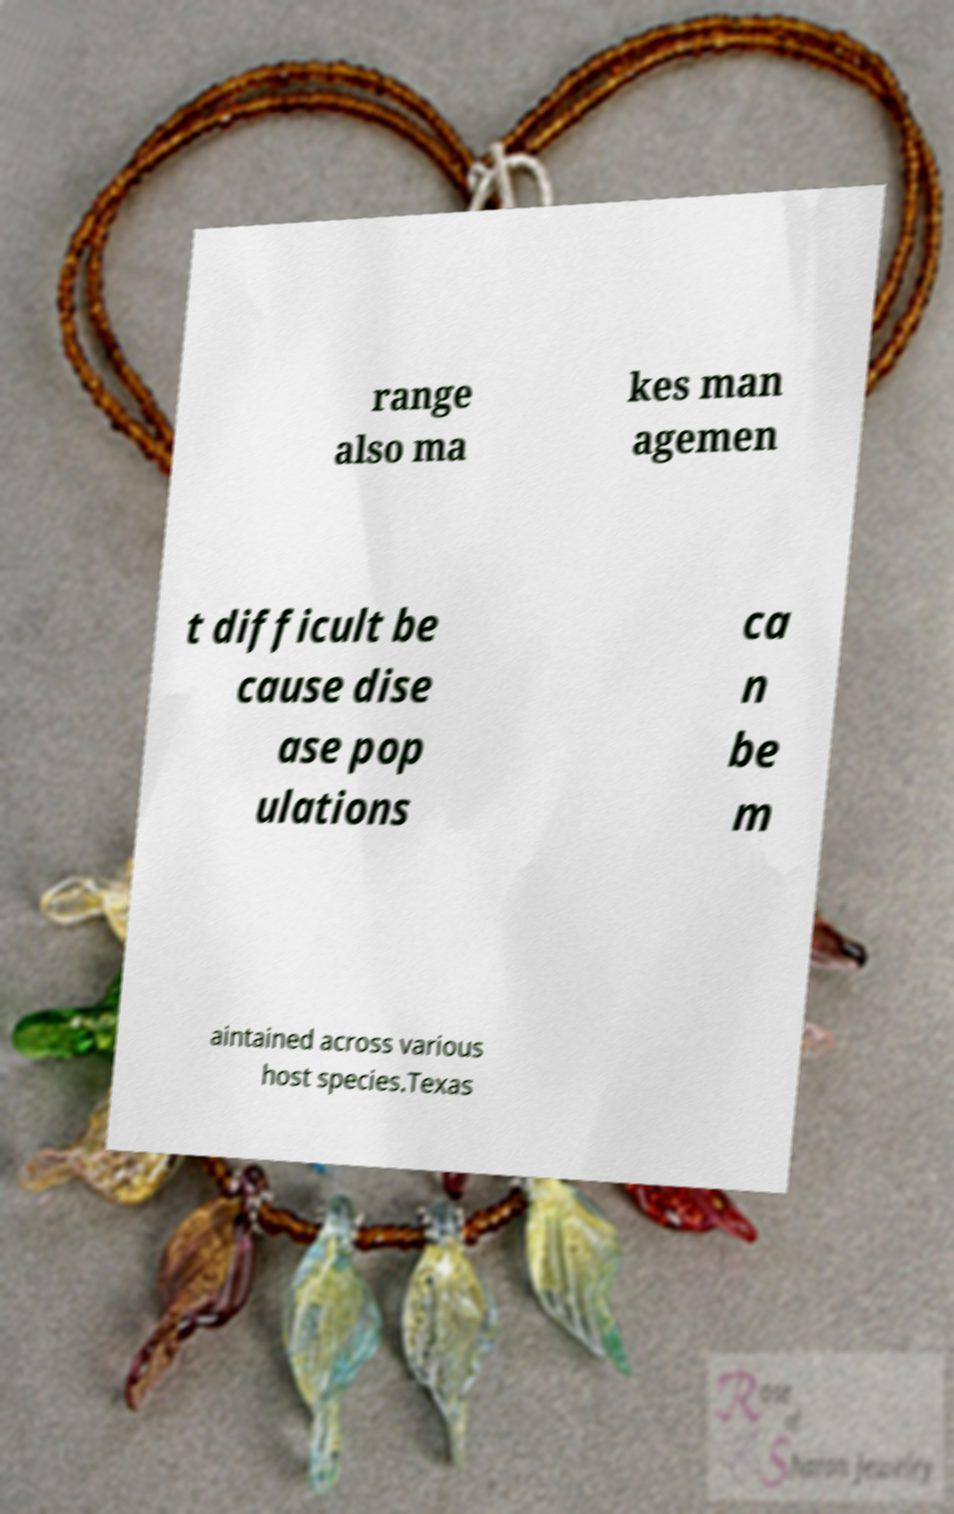Can you read and provide the text displayed in the image?This photo seems to have some interesting text. Can you extract and type it out for me? range also ma kes man agemen t difficult be cause dise ase pop ulations ca n be m aintained across various host species.Texas 